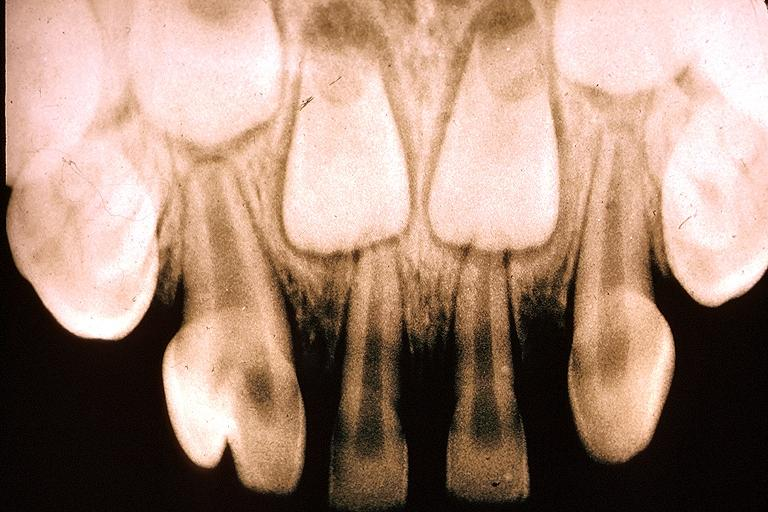s oral present?
Answer the question using a single word or phrase. Yes 